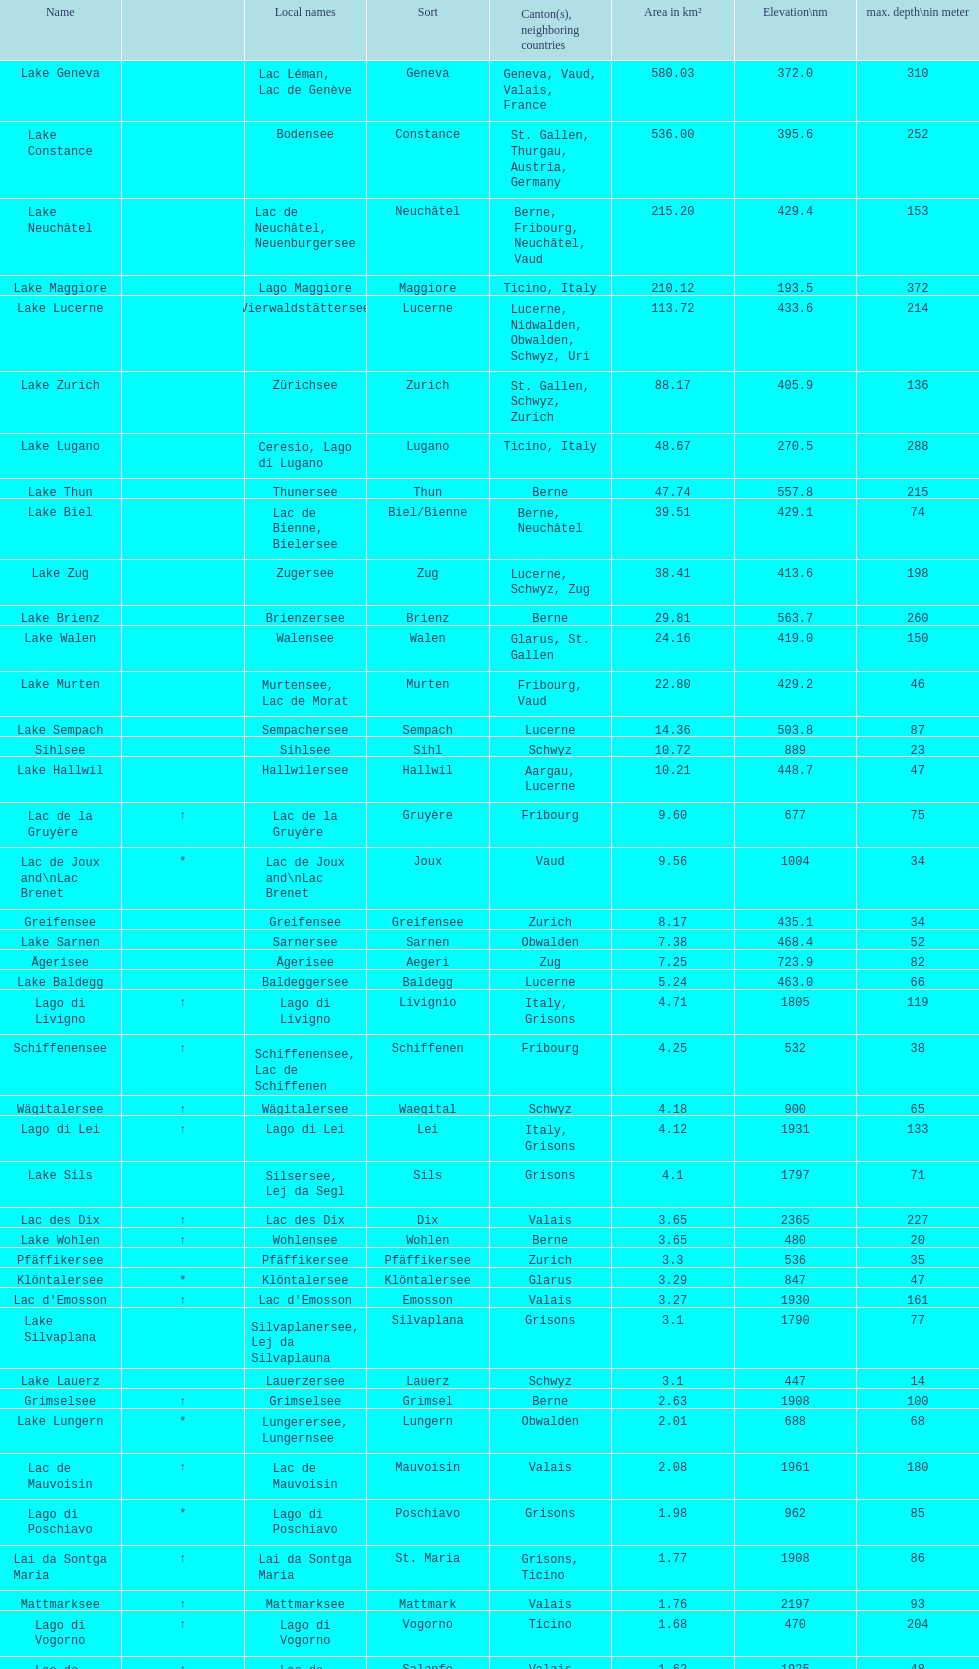What is the cumulative depth of the three deepest lakes? 970. 